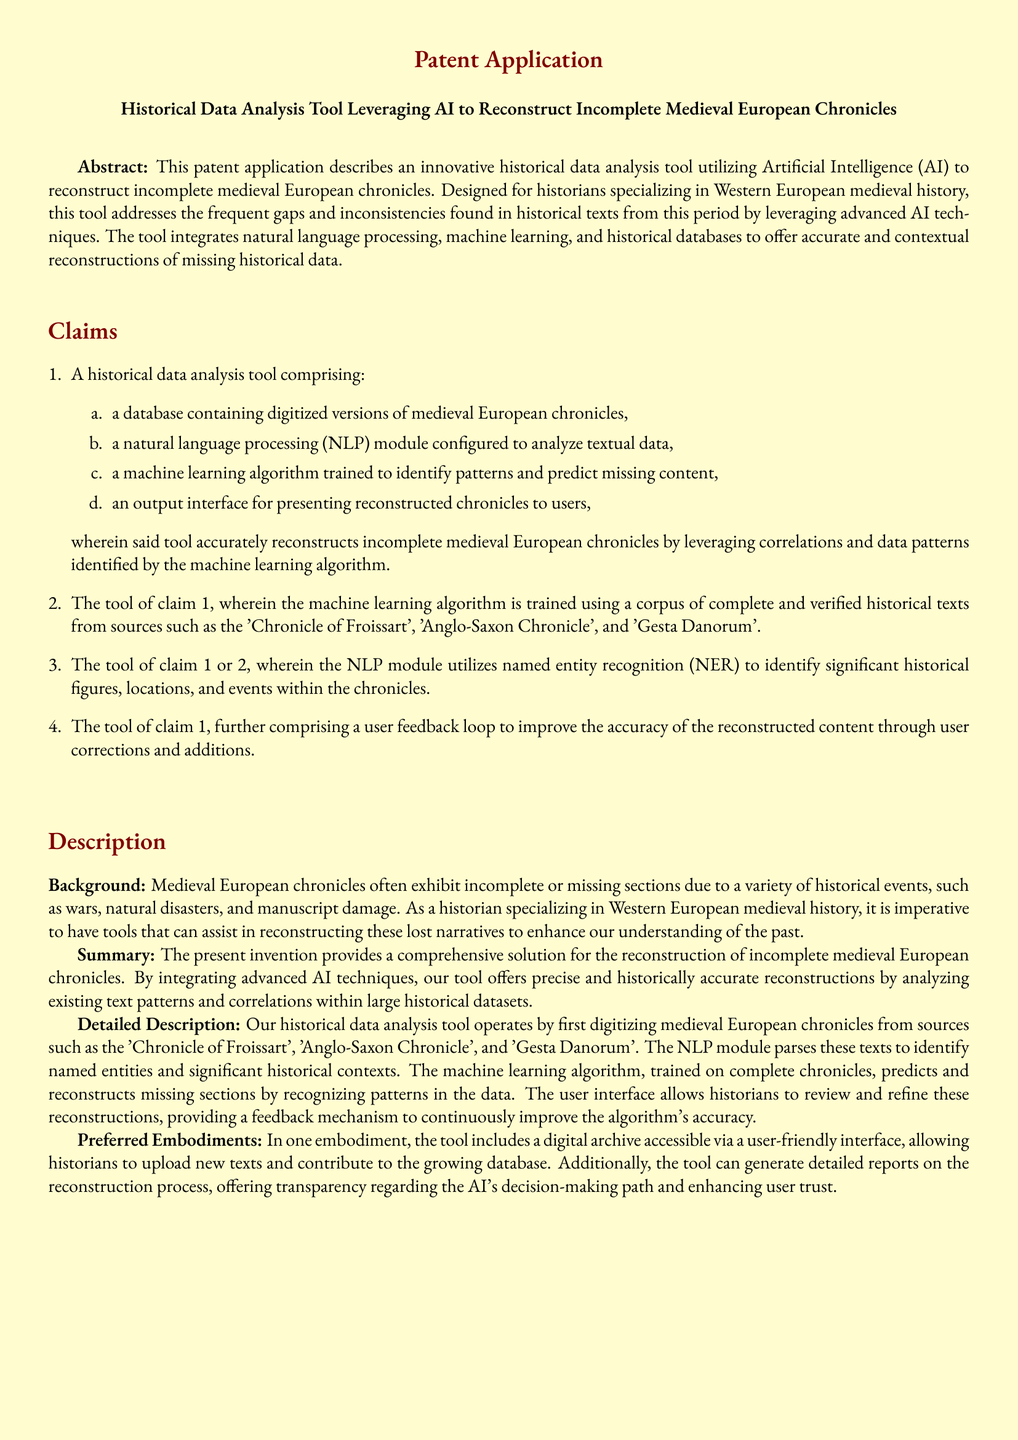What is the title of the patent application? The title is presented prominently at the top of the document, summarizing the tool’s purpose.
Answer: Historical Data Analysis Tool Leveraging AI to Reconstruct Incomplete Medieval European Chronicles What type of technology does the tool utilize? The technology used is mentioned in the abstract and claims, emphasizing its innovative approach.
Answer: Artificial Intelligence Name one source used to train the machine learning algorithm. The sources are specified in the claims section as examples of chronicles used for training.
Answer: Chronicle of Froissart What does the NLP module identify within the chronicles? The functions of the NLP module are discussed in the claims, highlighting its capabilities.
Answer: Significant historical figures, locations, and events How does the tool improve its accuracy? The document states that user corrections and additions help enhance the tool's performance.
Answer: User feedback loop What are the key components of the tool listed in the claims? The claims enumerate the essential parts that make up the tool as defined.
Answer: Database, NLP module, machine learning algorithm, output interface What historical issues does the tool address? The background section describes the problems the tool is designed to solve related to historical documents.
Answer: Incomplete or missing sections Which chronicles are digitized for this tool? The detailed description mentions specific texts that are digitized for analysis.
Answer: Chronicle of Froissart, Anglo-Saxon Chronicle, Gesta Danorum 